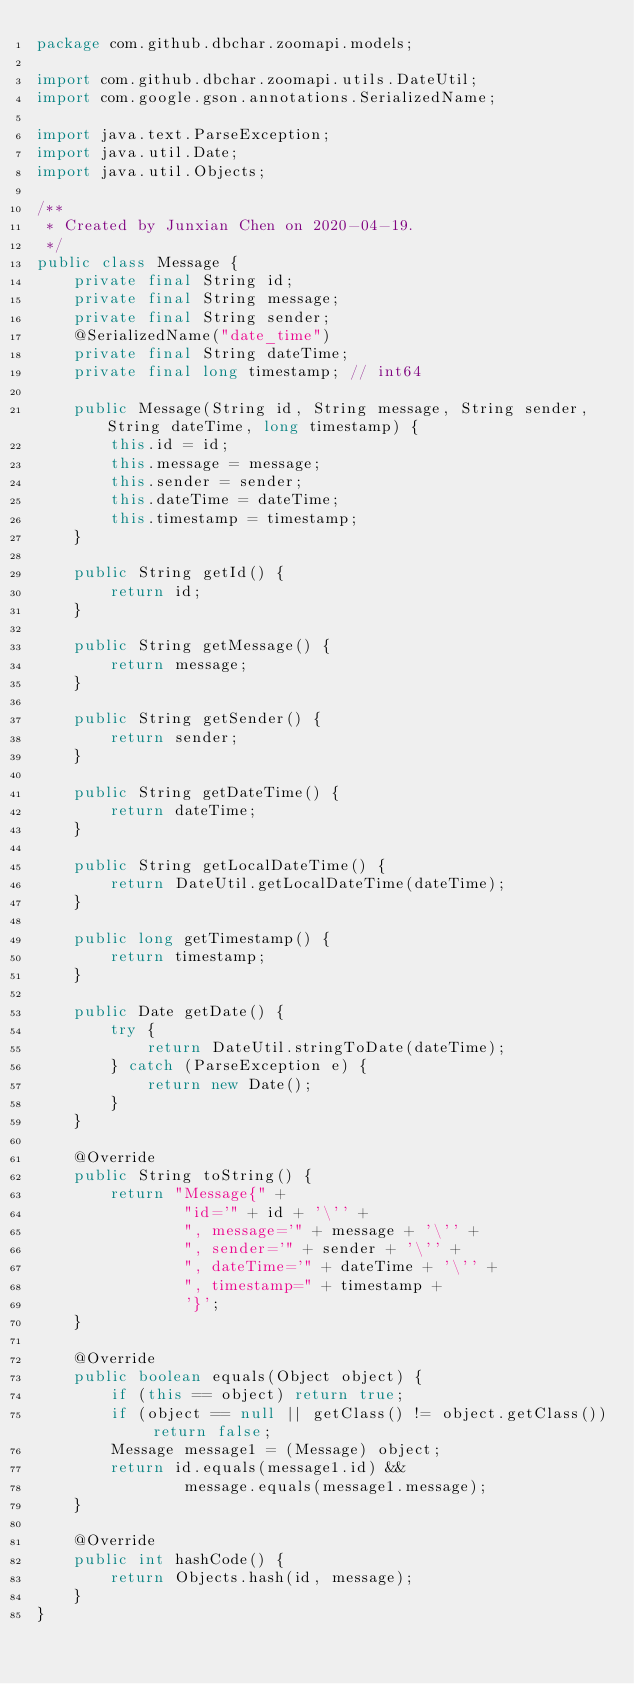Convert code to text. <code><loc_0><loc_0><loc_500><loc_500><_Java_>package com.github.dbchar.zoomapi.models;

import com.github.dbchar.zoomapi.utils.DateUtil;
import com.google.gson.annotations.SerializedName;

import java.text.ParseException;
import java.util.Date;
import java.util.Objects;

/**
 * Created by Junxian Chen on 2020-04-19.
 */
public class Message {
    private final String id;
    private final String message;
    private final String sender;
    @SerializedName("date_time")
    private final String dateTime;
    private final long timestamp; // int64

    public Message(String id, String message, String sender, String dateTime, long timestamp) {
        this.id = id;
        this.message = message;
        this.sender = sender;
        this.dateTime = dateTime;
        this.timestamp = timestamp;
    }

    public String getId() {
        return id;
    }

    public String getMessage() {
        return message;
    }

    public String getSender() {
        return sender;
    }

    public String getDateTime() {
        return dateTime;
    }

    public String getLocalDateTime() {
        return DateUtil.getLocalDateTime(dateTime);
    }

    public long getTimestamp() {
        return timestamp;
    }

    public Date getDate() {
        try {
            return DateUtil.stringToDate(dateTime);
        } catch (ParseException e) {
            return new Date();
        }
    }

    @Override
    public String toString() {
        return "Message{" +
                "id='" + id + '\'' +
                ", message='" + message + '\'' +
                ", sender='" + sender + '\'' +
                ", dateTime='" + dateTime + '\'' +
                ", timestamp=" + timestamp +
                '}';
    }

    @Override
    public boolean equals(Object object) {
        if (this == object) return true;
        if (object == null || getClass() != object.getClass()) return false;
        Message message1 = (Message) object;
        return id.equals(message1.id) &&
                message.equals(message1.message);
    }

    @Override
    public int hashCode() {
        return Objects.hash(id, message);
    }
}
</code> 